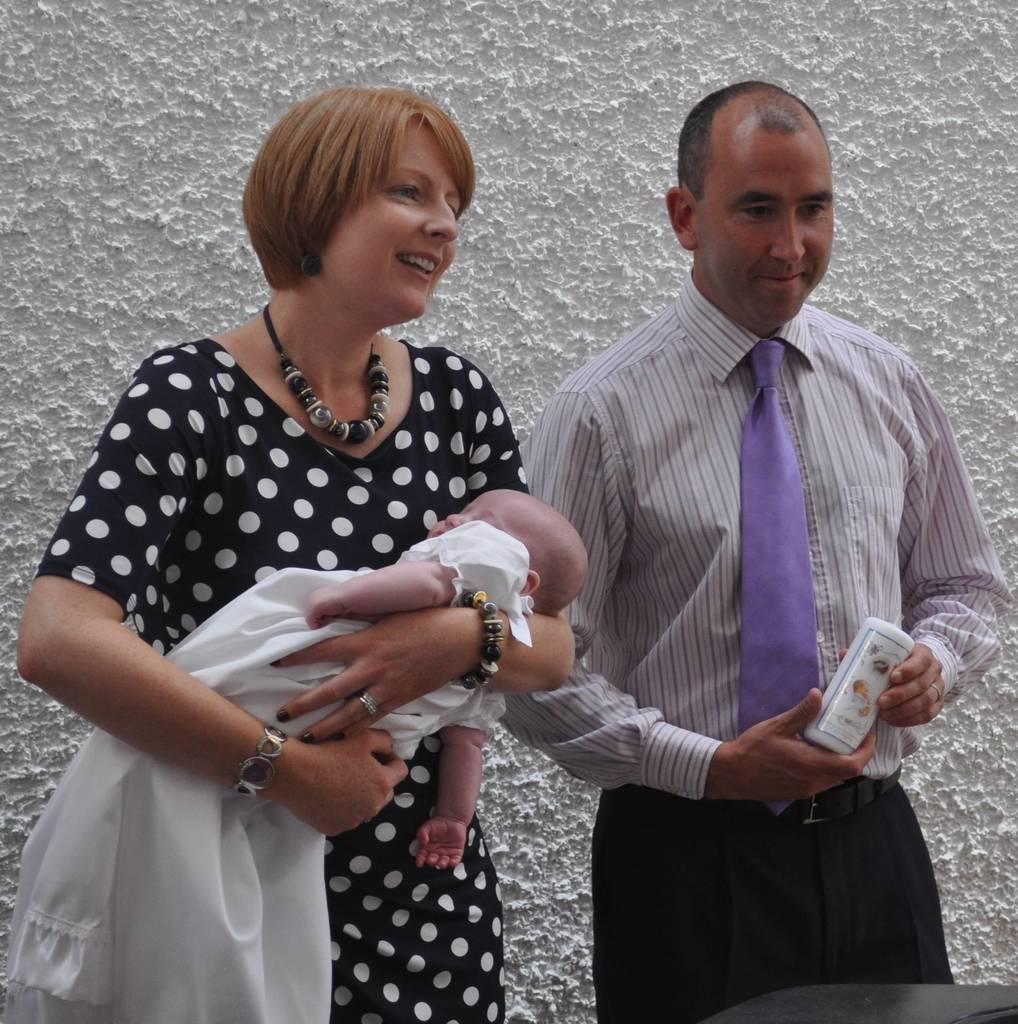Please provide a concise description of this image. In this picture there is a man who is wearing shirt and trouser. He is holding a book. Beside him we can see a woman who is holding a baby. She is wearing black dress and locket. In the back we can see white color wall. On the bottom right corner there is a black color table. 